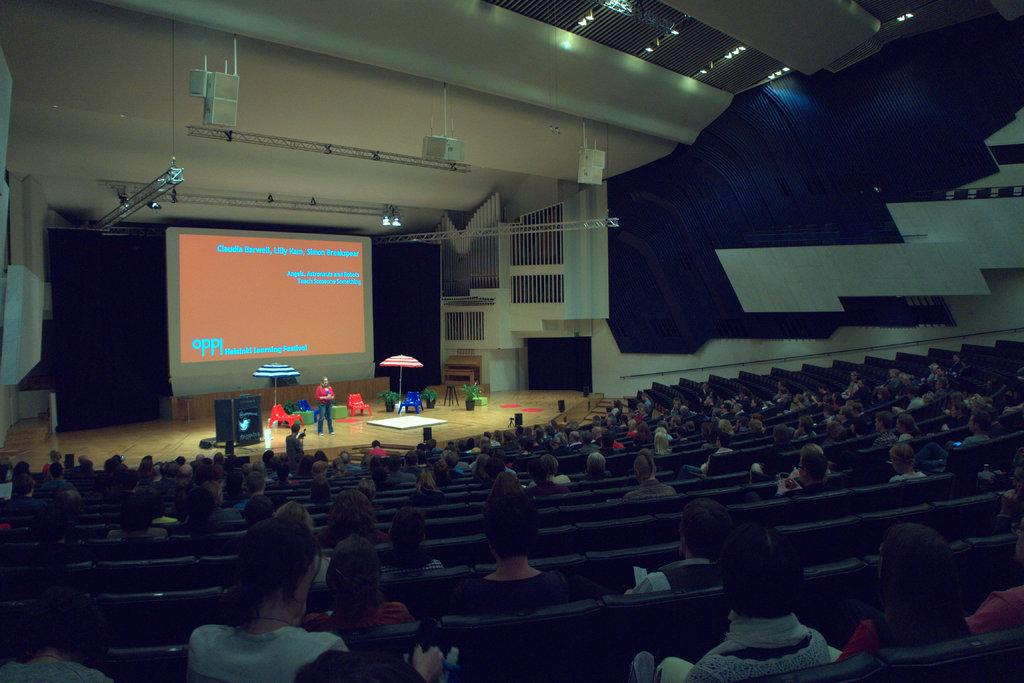<image>
Write a terse but informative summary of the picture. An auditorium full of people watching a powerpoint presentation organized by oppi  Helsinki Learning Festival. 